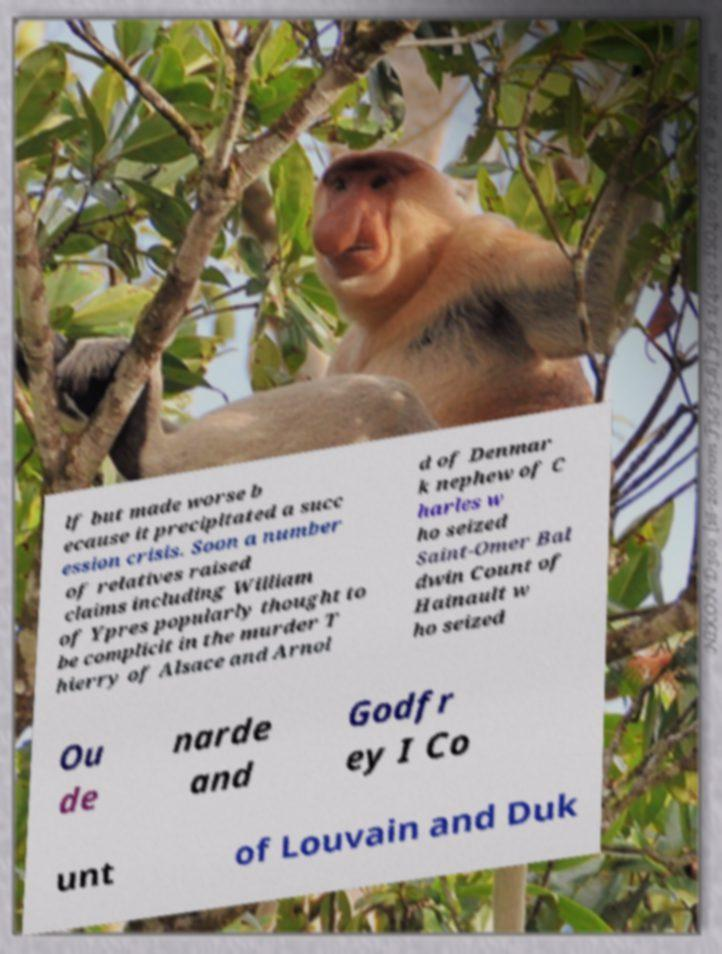There's text embedded in this image that I need extracted. Can you transcribe it verbatim? lf but made worse b ecause it precipitated a succ ession crisis. Soon a number of relatives raised claims including William of Ypres popularly thought to be complicit in the murder T hierry of Alsace and Arnol d of Denmar k nephew of C harles w ho seized Saint-Omer Bal dwin Count of Hainault w ho seized Ou de narde and Godfr ey I Co unt of Louvain and Duk 